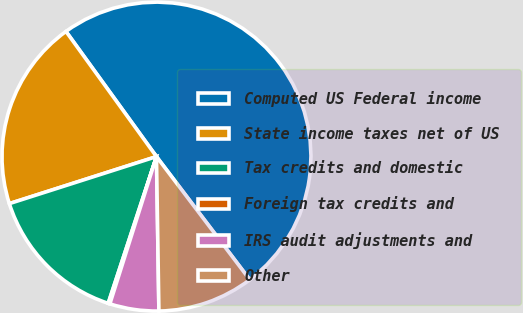Convert chart. <chart><loc_0><loc_0><loc_500><loc_500><pie_chart><fcel>Computed US Federal income<fcel>State income taxes net of US<fcel>Tax credits and domestic<fcel>Foreign tax credits and<fcel>IRS audit adjustments and<fcel>Other<nl><fcel>49.64%<fcel>19.96%<fcel>15.02%<fcel>0.18%<fcel>5.13%<fcel>10.07%<nl></chart> 